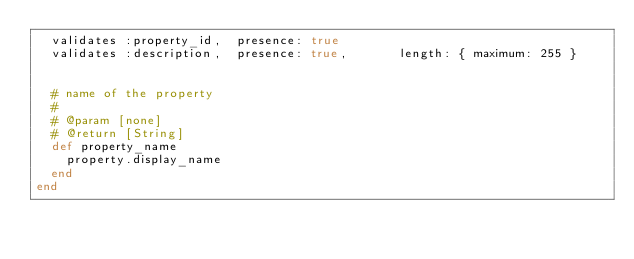Convert code to text. <code><loc_0><loc_0><loc_500><loc_500><_Ruby_>  validates :property_id,  presence: true
  validates :description,  presence: true,       length: { maximum: 255 }


  # name of the property
  #
  # @param [none]
  # @return [String]
  def property_name
    property.display_name
  end
end
</code> 